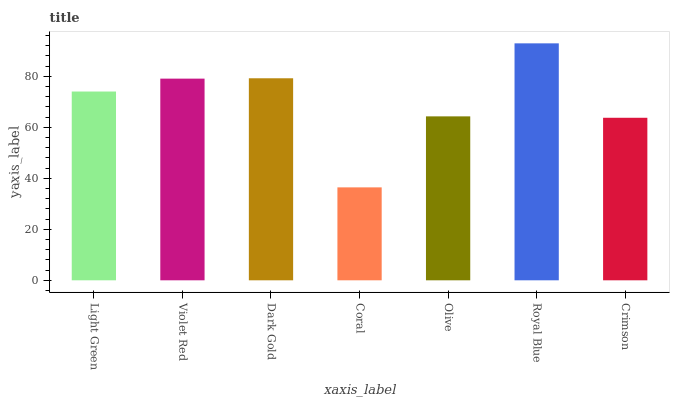Is Coral the minimum?
Answer yes or no. Yes. Is Royal Blue the maximum?
Answer yes or no. Yes. Is Violet Red the minimum?
Answer yes or no. No. Is Violet Red the maximum?
Answer yes or no. No. Is Violet Red greater than Light Green?
Answer yes or no. Yes. Is Light Green less than Violet Red?
Answer yes or no. Yes. Is Light Green greater than Violet Red?
Answer yes or no. No. Is Violet Red less than Light Green?
Answer yes or no. No. Is Light Green the high median?
Answer yes or no. Yes. Is Light Green the low median?
Answer yes or no. Yes. Is Coral the high median?
Answer yes or no. No. Is Coral the low median?
Answer yes or no. No. 